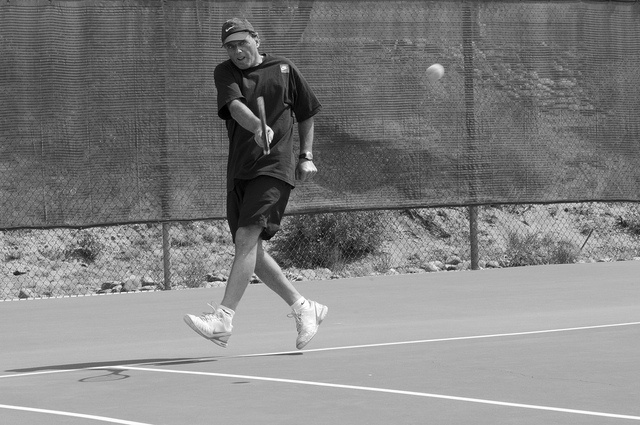Describe the objects in this image and their specific colors. I can see people in gray, black, darkgray, and gainsboro tones, tennis racket in gray, darkgray, black, and lightgray tones, and sports ball in darkgray, lightgray, and gray tones in this image. 